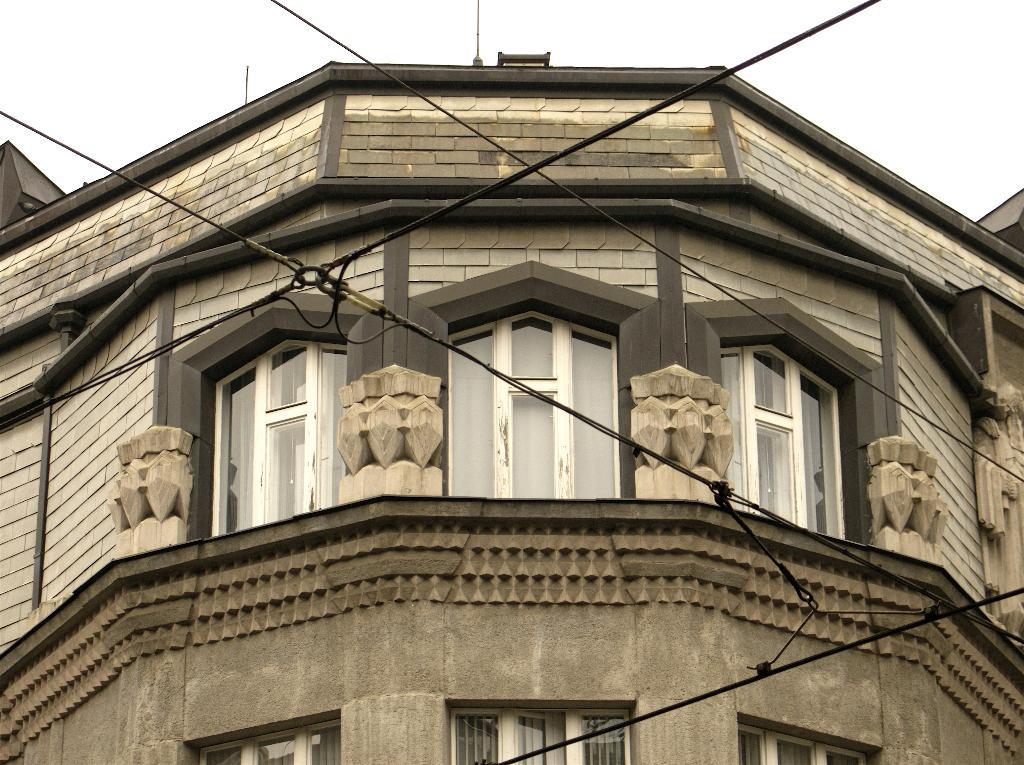What is the main subject in the center of the image? There is a building in the center of the image. What can be seen in the background of the image? The sky is visible in the background of the image. What type of appliance is being used to write a letter in the image? There is no appliance or letter present in the image; it only features a building and the sky. 